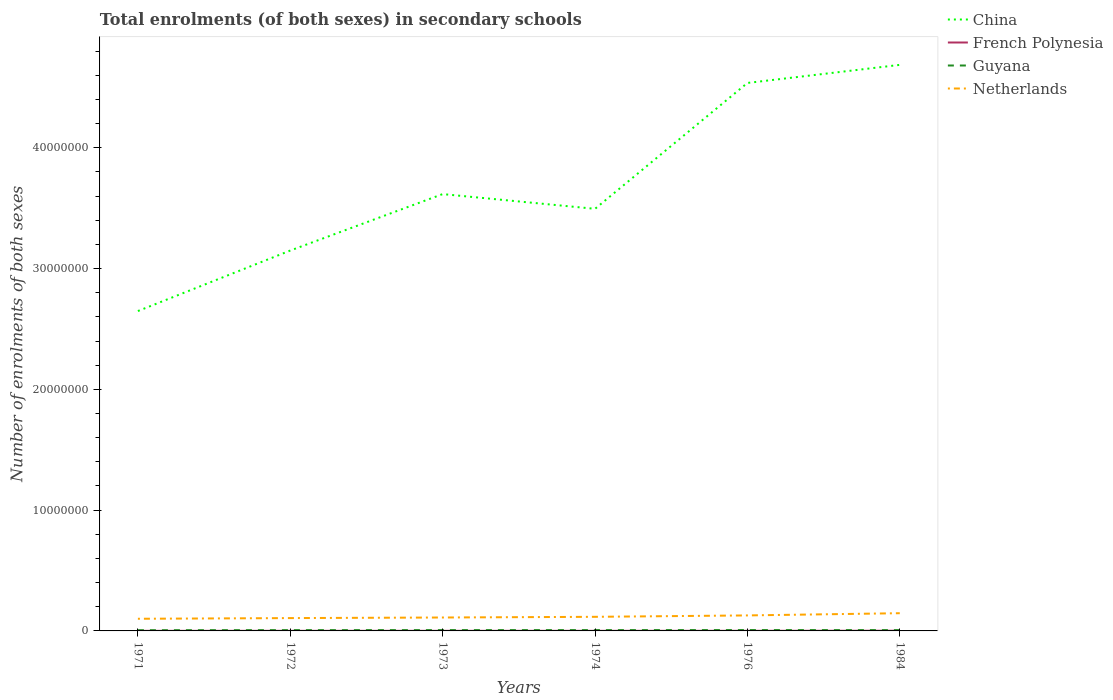Does the line corresponding to China intersect with the line corresponding to French Polynesia?
Offer a terse response. No. Is the number of lines equal to the number of legend labels?
Your response must be concise. Yes. Across all years, what is the maximum number of enrolments in secondary schools in Netherlands?
Offer a very short reply. 1.01e+06. In which year was the number of enrolments in secondary schools in Guyana maximum?
Give a very brief answer. 1971. What is the total number of enrolments in secondary schools in French Polynesia in the graph?
Provide a succinct answer. -1259. What is the difference between the highest and the second highest number of enrolments in secondary schools in Guyana?
Offer a very short reply. 1.09e+04. What is the difference between the highest and the lowest number of enrolments in secondary schools in Netherlands?
Ensure brevity in your answer.  2. How many lines are there?
Make the answer very short. 4. What is the difference between two consecutive major ticks on the Y-axis?
Your response must be concise. 1.00e+07. Are the values on the major ticks of Y-axis written in scientific E-notation?
Offer a terse response. No. Does the graph contain any zero values?
Your response must be concise. No. How are the legend labels stacked?
Make the answer very short. Vertical. What is the title of the graph?
Your answer should be compact. Total enrolments (of both sexes) in secondary schools. Does "Turks and Caicos Islands" appear as one of the legend labels in the graph?
Give a very brief answer. No. What is the label or title of the X-axis?
Your answer should be compact. Years. What is the label or title of the Y-axis?
Offer a very short reply. Number of enrolments of both sexes. What is the Number of enrolments of both sexes of China in 1971?
Your answer should be compact. 2.65e+07. What is the Number of enrolments of both sexes in French Polynesia in 1971?
Your answer should be compact. 6492. What is the Number of enrolments of both sexes of Guyana in 1971?
Keep it short and to the point. 6.04e+04. What is the Number of enrolments of both sexes in Netherlands in 1971?
Your answer should be compact. 1.01e+06. What is the Number of enrolments of both sexes of China in 1972?
Offer a very short reply. 3.15e+07. What is the Number of enrolments of both sexes of French Polynesia in 1972?
Offer a very short reply. 7542. What is the Number of enrolments of both sexes of Guyana in 1972?
Make the answer very short. 6.54e+04. What is the Number of enrolments of both sexes of Netherlands in 1972?
Offer a terse response. 1.06e+06. What is the Number of enrolments of both sexes in China in 1973?
Offer a very short reply. 3.62e+07. What is the Number of enrolments of both sexes in French Polynesia in 1973?
Provide a short and direct response. 7751. What is the Number of enrolments of both sexes in Guyana in 1973?
Give a very brief answer. 6.81e+04. What is the Number of enrolments of both sexes in Netherlands in 1973?
Offer a terse response. 1.11e+06. What is the Number of enrolments of both sexes of China in 1974?
Make the answer very short. 3.49e+07. What is the Number of enrolments of both sexes of French Polynesia in 1974?
Make the answer very short. 8126. What is the Number of enrolments of both sexes in Guyana in 1974?
Provide a short and direct response. 6.79e+04. What is the Number of enrolments of both sexes of Netherlands in 1974?
Your answer should be compact. 1.17e+06. What is the Number of enrolments of both sexes in China in 1976?
Ensure brevity in your answer.  4.54e+07. What is the Number of enrolments of both sexes of French Polynesia in 1976?
Offer a terse response. 9035. What is the Number of enrolments of both sexes in Guyana in 1976?
Keep it short and to the point. 7.13e+04. What is the Number of enrolments of both sexes in Netherlands in 1976?
Offer a very short reply. 1.28e+06. What is the Number of enrolments of both sexes of China in 1984?
Provide a succinct answer. 4.69e+07. What is the Number of enrolments of both sexes of French Polynesia in 1984?
Your response must be concise. 1.57e+04. What is the Number of enrolments of both sexes of Guyana in 1984?
Your response must be concise. 6.74e+04. What is the Number of enrolments of both sexes in Netherlands in 1984?
Offer a terse response. 1.47e+06. Across all years, what is the maximum Number of enrolments of both sexes in China?
Your response must be concise. 4.69e+07. Across all years, what is the maximum Number of enrolments of both sexes in French Polynesia?
Offer a terse response. 1.57e+04. Across all years, what is the maximum Number of enrolments of both sexes in Guyana?
Provide a short and direct response. 7.13e+04. Across all years, what is the maximum Number of enrolments of both sexes of Netherlands?
Ensure brevity in your answer.  1.47e+06. Across all years, what is the minimum Number of enrolments of both sexes in China?
Provide a short and direct response. 2.65e+07. Across all years, what is the minimum Number of enrolments of both sexes of French Polynesia?
Keep it short and to the point. 6492. Across all years, what is the minimum Number of enrolments of both sexes in Guyana?
Keep it short and to the point. 6.04e+04. Across all years, what is the minimum Number of enrolments of both sexes of Netherlands?
Provide a succinct answer. 1.01e+06. What is the total Number of enrolments of both sexes in China in the graph?
Your response must be concise. 2.21e+08. What is the total Number of enrolments of both sexes of French Polynesia in the graph?
Make the answer very short. 5.47e+04. What is the total Number of enrolments of both sexes of Guyana in the graph?
Make the answer very short. 4.00e+05. What is the total Number of enrolments of both sexes of Netherlands in the graph?
Ensure brevity in your answer.  7.10e+06. What is the difference between the Number of enrolments of both sexes in China in 1971 and that in 1972?
Give a very brief answer. -5.01e+06. What is the difference between the Number of enrolments of both sexes in French Polynesia in 1971 and that in 1972?
Your answer should be very brief. -1050. What is the difference between the Number of enrolments of both sexes of Guyana in 1971 and that in 1972?
Keep it short and to the point. -5000. What is the difference between the Number of enrolments of both sexes of Netherlands in 1971 and that in 1972?
Ensure brevity in your answer.  -5.63e+04. What is the difference between the Number of enrolments of both sexes in China in 1971 and that in 1973?
Offer a very short reply. -9.68e+06. What is the difference between the Number of enrolments of both sexes of French Polynesia in 1971 and that in 1973?
Your answer should be compact. -1259. What is the difference between the Number of enrolments of both sexes of Guyana in 1971 and that in 1973?
Ensure brevity in your answer.  -7680. What is the difference between the Number of enrolments of both sexes of Netherlands in 1971 and that in 1973?
Your answer should be compact. -1.05e+05. What is the difference between the Number of enrolments of both sexes of China in 1971 and that in 1974?
Your answer should be very brief. -8.46e+06. What is the difference between the Number of enrolments of both sexes in French Polynesia in 1971 and that in 1974?
Ensure brevity in your answer.  -1634. What is the difference between the Number of enrolments of both sexes of Guyana in 1971 and that in 1974?
Your answer should be very brief. -7441. What is the difference between the Number of enrolments of both sexes of Netherlands in 1971 and that in 1974?
Provide a succinct answer. -1.61e+05. What is the difference between the Number of enrolments of both sexes of China in 1971 and that in 1976?
Provide a short and direct response. -1.89e+07. What is the difference between the Number of enrolments of both sexes of French Polynesia in 1971 and that in 1976?
Keep it short and to the point. -2543. What is the difference between the Number of enrolments of both sexes in Guyana in 1971 and that in 1976?
Provide a succinct answer. -1.09e+04. What is the difference between the Number of enrolments of both sexes in Netherlands in 1971 and that in 1976?
Make the answer very short. -2.77e+05. What is the difference between the Number of enrolments of both sexes in China in 1971 and that in 1984?
Offer a very short reply. -2.04e+07. What is the difference between the Number of enrolments of both sexes of French Polynesia in 1971 and that in 1984?
Give a very brief answer. -9255. What is the difference between the Number of enrolments of both sexes of Guyana in 1971 and that in 1984?
Provide a succinct answer. -6950. What is the difference between the Number of enrolments of both sexes in Netherlands in 1971 and that in 1984?
Give a very brief answer. -4.61e+05. What is the difference between the Number of enrolments of both sexes in China in 1972 and that in 1973?
Your answer should be very brief. -4.67e+06. What is the difference between the Number of enrolments of both sexes of French Polynesia in 1972 and that in 1973?
Keep it short and to the point. -209. What is the difference between the Number of enrolments of both sexes in Guyana in 1972 and that in 1973?
Your answer should be very brief. -2680. What is the difference between the Number of enrolments of both sexes in Netherlands in 1972 and that in 1973?
Keep it short and to the point. -4.83e+04. What is the difference between the Number of enrolments of both sexes of China in 1972 and that in 1974?
Ensure brevity in your answer.  -3.45e+06. What is the difference between the Number of enrolments of both sexes in French Polynesia in 1972 and that in 1974?
Keep it short and to the point. -584. What is the difference between the Number of enrolments of both sexes of Guyana in 1972 and that in 1974?
Keep it short and to the point. -2441. What is the difference between the Number of enrolments of both sexes in Netherlands in 1972 and that in 1974?
Provide a succinct answer. -1.05e+05. What is the difference between the Number of enrolments of both sexes of China in 1972 and that in 1976?
Provide a short and direct response. -1.39e+07. What is the difference between the Number of enrolments of both sexes of French Polynesia in 1972 and that in 1976?
Your answer should be compact. -1493. What is the difference between the Number of enrolments of both sexes of Guyana in 1972 and that in 1976?
Make the answer very short. -5915. What is the difference between the Number of enrolments of both sexes in Netherlands in 1972 and that in 1976?
Provide a succinct answer. -2.21e+05. What is the difference between the Number of enrolments of both sexes of China in 1972 and that in 1984?
Your answer should be compact. -1.54e+07. What is the difference between the Number of enrolments of both sexes in French Polynesia in 1972 and that in 1984?
Provide a succinct answer. -8205. What is the difference between the Number of enrolments of both sexes of Guyana in 1972 and that in 1984?
Provide a short and direct response. -1950. What is the difference between the Number of enrolments of both sexes of Netherlands in 1972 and that in 1984?
Offer a very short reply. -4.04e+05. What is the difference between the Number of enrolments of both sexes of China in 1973 and that in 1974?
Give a very brief answer. 1.22e+06. What is the difference between the Number of enrolments of both sexes in French Polynesia in 1973 and that in 1974?
Make the answer very short. -375. What is the difference between the Number of enrolments of both sexes in Guyana in 1973 and that in 1974?
Provide a succinct answer. 239. What is the difference between the Number of enrolments of both sexes in Netherlands in 1973 and that in 1974?
Ensure brevity in your answer.  -5.65e+04. What is the difference between the Number of enrolments of both sexes in China in 1973 and that in 1976?
Give a very brief answer. -9.20e+06. What is the difference between the Number of enrolments of both sexes in French Polynesia in 1973 and that in 1976?
Your answer should be compact. -1284. What is the difference between the Number of enrolments of both sexes in Guyana in 1973 and that in 1976?
Make the answer very short. -3235. What is the difference between the Number of enrolments of both sexes of Netherlands in 1973 and that in 1976?
Your response must be concise. -1.73e+05. What is the difference between the Number of enrolments of both sexes in China in 1973 and that in 1984?
Offer a very short reply. -1.07e+07. What is the difference between the Number of enrolments of both sexes in French Polynesia in 1973 and that in 1984?
Provide a short and direct response. -7996. What is the difference between the Number of enrolments of both sexes of Guyana in 1973 and that in 1984?
Give a very brief answer. 730. What is the difference between the Number of enrolments of both sexes of Netherlands in 1973 and that in 1984?
Your answer should be very brief. -3.56e+05. What is the difference between the Number of enrolments of both sexes in China in 1974 and that in 1976?
Your answer should be compact. -1.04e+07. What is the difference between the Number of enrolments of both sexes in French Polynesia in 1974 and that in 1976?
Make the answer very short. -909. What is the difference between the Number of enrolments of both sexes of Guyana in 1974 and that in 1976?
Your answer should be very brief. -3474. What is the difference between the Number of enrolments of both sexes of Netherlands in 1974 and that in 1976?
Offer a terse response. -1.16e+05. What is the difference between the Number of enrolments of both sexes of China in 1974 and that in 1984?
Make the answer very short. -1.19e+07. What is the difference between the Number of enrolments of both sexes in French Polynesia in 1974 and that in 1984?
Offer a very short reply. -7621. What is the difference between the Number of enrolments of both sexes in Guyana in 1974 and that in 1984?
Ensure brevity in your answer.  491. What is the difference between the Number of enrolments of both sexes of Netherlands in 1974 and that in 1984?
Provide a succinct answer. -2.99e+05. What is the difference between the Number of enrolments of both sexes in China in 1976 and that in 1984?
Provide a short and direct response. -1.50e+06. What is the difference between the Number of enrolments of both sexes in French Polynesia in 1976 and that in 1984?
Offer a very short reply. -6712. What is the difference between the Number of enrolments of both sexes in Guyana in 1976 and that in 1984?
Make the answer very short. 3965. What is the difference between the Number of enrolments of both sexes of Netherlands in 1976 and that in 1984?
Your answer should be very brief. -1.83e+05. What is the difference between the Number of enrolments of both sexes in China in 1971 and the Number of enrolments of both sexes in French Polynesia in 1972?
Keep it short and to the point. 2.65e+07. What is the difference between the Number of enrolments of both sexes in China in 1971 and the Number of enrolments of both sexes in Guyana in 1972?
Your response must be concise. 2.64e+07. What is the difference between the Number of enrolments of both sexes of China in 1971 and the Number of enrolments of both sexes of Netherlands in 1972?
Your response must be concise. 2.54e+07. What is the difference between the Number of enrolments of both sexes in French Polynesia in 1971 and the Number of enrolments of both sexes in Guyana in 1972?
Your response must be concise. -5.89e+04. What is the difference between the Number of enrolments of both sexes in French Polynesia in 1971 and the Number of enrolments of both sexes in Netherlands in 1972?
Give a very brief answer. -1.06e+06. What is the difference between the Number of enrolments of both sexes in Guyana in 1971 and the Number of enrolments of both sexes in Netherlands in 1972?
Offer a very short reply. -1.00e+06. What is the difference between the Number of enrolments of both sexes of China in 1971 and the Number of enrolments of both sexes of French Polynesia in 1973?
Provide a succinct answer. 2.65e+07. What is the difference between the Number of enrolments of both sexes of China in 1971 and the Number of enrolments of both sexes of Guyana in 1973?
Offer a terse response. 2.64e+07. What is the difference between the Number of enrolments of both sexes in China in 1971 and the Number of enrolments of both sexes in Netherlands in 1973?
Your answer should be compact. 2.54e+07. What is the difference between the Number of enrolments of both sexes of French Polynesia in 1971 and the Number of enrolments of both sexes of Guyana in 1973?
Provide a succinct answer. -6.16e+04. What is the difference between the Number of enrolments of both sexes of French Polynesia in 1971 and the Number of enrolments of both sexes of Netherlands in 1973?
Your answer should be very brief. -1.10e+06. What is the difference between the Number of enrolments of both sexes of Guyana in 1971 and the Number of enrolments of both sexes of Netherlands in 1973?
Your answer should be compact. -1.05e+06. What is the difference between the Number of enrolments of both sexes of China in 1971 and the Number of enrolments of both sexes of French Polynesia in 1974?
Give a very brief answer. 2.65e+07. What is the difference between the Number of enrolments of both sexes of China in 1971 and the Number of enrolments of both sexes of Guyana in 1974?
Offer a very short reply. 2.64e+07. What is the difference between the Number of enrolments of both sexes of China in 1971 and the Number of enrolments of both sexes of Netherlands in 1974?
Offer a very short reply. 2.53e+07. What is the difference between the Number of enrolments of both sexes of French Polynesia in 1971 and the Number of enrolments of both sexes of Guyana in 1974?
Your answer should be very brief. -6.14e+04. What is the difference between the Number of enrolments of both sexes in French Polynesia in 1971 and the Number of enrolments of both sexes in Netherlands in 1974?
Make the answer very short. -1.16e+06. What is the difference between the Number of enrolments of both sexes in Guyana in 1971 and the Number of enrolments of both sexes in Netherlands in 1974?
Your answer should be compact. -1.11e+06. What is the difference between the Number of enrolments of both sexes of China in 1971 and the Number of enrolments of both sexes of French Polynesia in 1976?
Offer a terse response. 2.65e+07. What is the difference between the Number of enrolments of both sexes of China in 1971 and the Number of enrolments of both sexes of Guyana in 1976?
Your answer should be compact. 2.64e+07. What is the difference between the Number of enrolments of both sexes of China in 1971 and the Number of enrolments of both sexes of Netherlands in 1976?
Your answer should be compact. 2.52e+07. What is the difference between the Number of enrolments of both sexes in French Polynesia in 1971 and the Number of enrolments of both sexes in Guyana in 1976?
Provide a succinct answer. -6.48e+04. What is the difference between the Number of enrolments of both sexes in French Polynesia in 1971 and the Number of enrolments of both sexes in Netherlands in 1976?
Keep it short and to the point. -1.28e+06. What is the difference between the Number of enrolments of both sexes of Guyana in 1971 and the Number of enrolments of both sexes of Netherlands in 1976?
Give a very brief answer. -1.22e+06. What is the difference between the Number of enrolments of both sexes of China in 1971 and the Number of enrolments of both sexes of French Polynesia in 1984?
Offer a terse response. 2.65e+07. What is the difference between the Number of enrolments of both sexes in China in 1971 and the Number of enrolments of both sexes in Guyana in 1984?
Keep it short and to the point. 2.64e+07. What is the difference between the Number of enrolments of both sexes in China in 1971 and the Number of enrolments of both sexes in Netherlands in 1984?
Offer a very short reply. 2.50e+07. What is the difference between the Number of enrolments of both sexes in French Polynesia in 1971 and the Number of enrolments of both sexes in Guyana in 1984?
Give a very brief answer. -6.09e+04. What is the difference between the Number of enrolments of both sexes in French Polynesia in 1971 and the Number of enrolments of both sexes in Netherlands in 1984?
Offer a very short reply. -1.46e+06. What is the difference between the Number of enrolments of both sexes in Guyana in 1971 and the Number of enrolments of both sexes in Netherlands in 1984?
Your answer should be very brief. -1.41e+06. What is the difference between the Number of enrolments of both sexes in China in 1972 and the Number of enrolments of both sexes in French Polynesia in 1973?
Your answer should be compact. 3.15e+07. What is the difference between the Number of enrolments of both sexes of China in 1972 and the Number of enrolments of both sexes of Guyana in 1973?
Give a very brief answer. 3.14e+07. What is the difference between the Number of enrolments of both sexes in China in 1972 and the Number of enrolments of both sexes in Netherlands in 1973?
Offer a terse response. 3.04e+07. What is the difference between the Number of enrolments of both sexes of French Polynesia in 1972 and the Number of enrolments of both sexes of Guyana in 1973?
Give a very brief answer. -6.06e+04. What is the difference between the Number of enrolments of both sexes of French Polynesia in 1972 and the Number of enrolments of both sexes of Netherlands in 1973?
Provide a succinct answer. -1.10e+06. What is the difference between the Number of enrolments of both sexes of Guyana in 1972 and the Number of enrolments of both sexes of Netherlands in 1973?
Give a very brief answer. -1.05e+06. What is the difference between the Number of enrolments of both sexes of China in 1972 and the Number of enrolments of both sexes of French Polynesia in 1974?
Ensure brevity in your answer.  3.15e+07. What is the difference between the Number of enrolments of both sexes of China in 1972 and the Number of enrolments of both sexes of Guyana in 1974?
Offer a terse response. 3.14e+07. What is the difference between the Number of enrolments of both sexes of China in 1972 and the Number of enrolments of both sexes of Netherlands in 1974?
Provide a short and direct response. 3.03e+07. What is the difference between the Number of enrolments of both sexes of French Polynesia in 1972 and the Number of enrolments of both sexes of Guyana in 1974?
Offer a very short reply. -6.03e+04. What is the difference between the Number of enrolments of both sexes of French Polynesia in 1972 and the Number of enrolments of both sexes of Netherlands in 1974?
Your answer should be compact. -1.16e+06. What is the difference between the Number of enrolments of both sexes in Guyana in 1972 and the Number of enrolments of both sexes in Netherlands in 1974?
Provide a succinct answer. -1.10e+06. What is the difference between the Number of enrolments of both sexes of China in 1972 and the Number of enrolments of both sexes of French Polynesia in 1976?
Offer a terse response. 3.15e+07. What is the difference between the Number of enrolments of both sexes in China in 1972 and the Number of enrolments of both sexes in Guyana in 1976?
Your answer should be compact. 3.14e+07. What is the difference between the Number of enrolments of both sexes of China in 1972 and the Number of enrolments of both sexes of Netherlands in 1976?
Ensure brevity in your answer.  3.02e+07. What is the difference between the Number of enrolments of both sexes of French Polynesia in 1972 and the Number of enrolments of both sexes of Guyana in 1976?
Your response must be concise. -6.38e+04. What is the difference between the Number of enrolments of both sexes in French Polynesia in 1972 and the Number of enrolments of both sexes in Netherlands in 1976?
Your answer should be very brief. -1.28e+06. What is the difference between the Number of enrolments of both sexes of Guyana in 1972 and the Number of enrolments of both sexes of Netherlands in 1976?
Your answer should be compact. -1.22e+06. What is the difference between the Number of enrolments of both sexes in China in 1972 and the Number of enrolments of both sexes in French Polynesia in 1984?
Offer a terse response. 3.15e+07. What is the difference between the Number of enrolments of both sexes of China in 1972 and the Number of enrolments of both sexes of Guyana in 1984?
Offer a terse response. 3.14e+07. What is the difference between the Number of enrolments of both sexes in China in 1972 and the Number of enrolments of both sexes in Netherlands in 1984?
Keep it short and to the point. 3.00e+07. What is the difference between the Number of enrolments of both sexes of French Polynesia in 1972 and the Number of enrolments of both sexes of Guyana in 1984?
Your response must be concise. -5.98e+04. What is the difference between the Number of enrolments of both sexes in French Polynesia in 1972 and the Number of enrolments of both sexes in Netherlands in 1984?
Keep it short and to the point. -1.46e+06. What is the difference between the Number of enrolments of both sexes in Guyana in 1972 and the Number of enrolments of both sexes in Netherlands in 1984?
Make the answer very short. -1.40e+06. What is the difference between the Number of enrolments of both sexes in China in 1973 and the Number of enrolments of both sexes in French Polynesia in 1974?
Give a very brief answer. 3.62e+07. What is the difference between the Number of enrolments of both sexes of China in 1973 and the Number of enrolments of both sexes of Guyana in 1974?
Keep it short and to the point. 3.61e+07. What is the difference between the Number of enrolments of both sexes in China in 1973 and the Number of enrolments of both sexes in Netherlands in 1974?
Your response must be concise. 3.50e+07. What is the difference between the Number of enrolments of both sexes in French Polynesia in 1973 and the Number of enrolments of both sexes in Guyana in 1974?
Your answer should be very brief. -6.01e+04. What is the difference between the Number of enrolments of both sexes of French Polynesia in 1973 and the Number of enrolments of both sexes of Netherlands in 1974?
Your answer should be very brief. -1.16e+06. What is the difference between the Number of enrolments of both sexes in Guyana in 1973 and the Number of enrolments of both sexes in Netherlands in 1974?
Provide a succinct answer. -1.10e+06. What is the difference between the Number of enrolments of both sexes in China in 1973 and the Number of enrolments of both sexes in French Polynesia in 1976?
Ensure brevity in your answer.  3.62e+07. What is the difference between the Number of enrolments of both sexes of China in 1973 and the Number of enrolments of both sexes of Guyana in 1976?
Offer a very short reply. 3.61e+07. What is the difference between the Number of enrolments of both sexes of China in 1973 and the Number of enrolments of both sexes of Netherlands in 1976?
Your answer should be compact. 3.49e+07. What is the difference between the Number of enrolments of both sexes of French Polynesia in 1973 and the Number of enrolments of both sexes of Guyana in 1976?
Offer a very short reply. -6.36e+04. What is the difference between the Number of enrolments of both sexes in French Polynesia in 1973 and the Number of enrolments of both sexes in Netherlands in 1976?
Ensure brevity in your answer.  -1.28e+06. What is the difference between the Number of enrolments of both sexes in Guyana in 1973 and the Number of enrolments of both sexes in Netherlands in 1976?
Ensure brevity in your answer.  -1.22e+06. What is the difference between the Number of enrolments of both sexes of China in 1973 and the Number of enrolments of both sexes of French Polynesia in 1984?
Your answer should be very brief. 3.62e+07. What is the difference between the Number of enrolments of both sexes in China in 1973 and the Number of enrolments of both sexes in Guyana in 1984?
Give a very brief answer. 3.61e+07. What is the difference between the Number of enrolments of both sexes in China in 1973 and the Number of enrolments of both sexes in Netherlands in 1984?
Give a very brief answer. 3.47e+07. What is the difference between the Number of enrolments of both sexes in French Polynesia in 1973 and the Number of enrolments of both sexes in Guyana in 1984?
Provide a succinct answer. -5.96e+04. What is the difference between the Number of enrolments of both sexes of French Polynesia in 1973 and the Number of enrolments of both sexes of Netherlands in 1984?
Make the answer very short. -1.46e+06. What is the difference between the Number of enrolments of both sexes in Guyana in 1973 and the Number of enrolments of both sexes in Netherlands in 1984?
Your answer should be very brief. -1.40e+06. What is the difference between the Number of enrolments of both sexes of China in 1974 and the Number of enrolments of both sexes of French Polynesia in 1976?
Offer a very short reply. 3.49e+07. What is the difference between the Number of enrolments of both sexes of China in 1974 and the Number of enrolments of both sexes of Guyana in 1976?
Keep it short and to the point. 3.49e+07. What is the difference between the Number of enrolments of both sexes in China in 1974 and the Number of enrolments of both sexes in Netherlands in 1976?
Provide a short and direct response. 3.37e+07. What is the difference between the Number of enrolments of both sexes in French Polynesia in 1974 and the Number of enrolments of both sexes in Guyana in 1976?
Provide a succinct answer. -6.32e+04. What is the difference between the Number of enrolments of both sexes of French Polynesia in 1974 and the Number of enrolments of both sexes of Netherlands in 1976?
Your answer should be very brief. -1.28e+06. What is the difference between the Number of enrolments of both sexes in Guyana in 1974 and the Number of enrolments of both sexes in Netherlands in 1976?
Ensure brevity in your answer.  -1.22e+06. What is the difference between the Number of enrolments of both sexes in China in 1974 and the Number of enrolments of both sexes in French Polynesia in 1984?
Make the answer very short. 3.49e+07. What is the difference between the Number of enrolments of both sexes in China in 1974 and the Number of enrolments of both sexes in Guyana in 1984?
Provide a short and direct response. 3.49e+07. What is the difference between the Number of enrolments of both sexes in China in 1974 and the Number of enrolments of both sexes in Netherlands in 1984?
Keep it short and to the point. 3.35e+07. What is the difference between the Number of enrolments of both sexes in French Polynesia in 1974 and the Number of enrolments of both sexes in Guyana in 1984?
Give a very brief answer. -5.92e+04. What is the difference between the Number of enrolments of both sexes of French Polynesia in 1974 and the Number of enrolments of both sexes of Netherlands in 1984?
Keep it short and to the point. -1.46e+06. What is the difference between the Number of enrolments of both sexes of Guyana in 1974 and the Number of enrolments of both sexes of Netherlands in 1984?
Offer a terse response. -1.40e+06. What is the difference between the Number of enrolments of both sexes of China in 1976 and the Number of enrolments of both sexes of French Polynesia in 1984?
Ensure brevity in your answer.  4.54e+07. What is the difference between the Number of enrolments of both sexes in China in 1976 and the Number of enrolments of both sexes in Guyana in 1984?
Your answer should be very brief. 4.53e+07. What is the difference between the Number of enrolments of both sexes of China in 1976 and the Number of enrolments of both sexes of Netherlands in 1984?
Your answer should be compact. 4.39e+07. What is the difference between the Number of enrolments of both sexes in French Polynesia in 1976 and the Number of enrolments of both sexes in Guyana in 1984?
Offer a terse response. -5.83e+04. What is the difference between the Number of enrolments of both sexes in French Polynesia in 1976 and the Number of enrolments of both sexes in Netherlands in 1984?
Your response must be concise. -1.46e+06. What is the difference between the Number of enrolments of both sexes of Guyana in 1976 and the Number of enrolments of both sexes of Netherlands in 1984?
Your answer should be very brief. -1.40e+06. What is the average Number of enrolments of both sexes in China per year?
Your response must be concise. 3.69e+07. What is the average Number of enrolments of both sexes in French Polynesia per year?
Give a very brief answer. 9115.5. What is the average Number of enrolments of both sexes of Guyana per year?
Offer a very short reply. 6.67e+04. What is the average Number of enrolments of both sexes of Netherlands per year?
Offer a terse response. 1.18e+06. In the year 1971, what is the difference between the Number of enrolments of both sexes in China and Number of enrolments of both sexes in French Polynesia?
Offer a very short reply. 2.65e+07. In the year 1971, what is the difference between the Number of enrolments of both sexes of China and Number of enrolments of both sexes of Guyana?
Provide a succinct answer. 2.64e+07. In the year 1971, what is the difference between the Number of enrolments of both sexes of China and Number of enrolments of both sexes of Netherlands?
Your response must be concise. 2.55e+07. In the year 1971, what is the difference between the Number of enrolments of both sexes of French Polynesia and Number of enrolments of both sexes of Guyana?
Make the answer very short. -5.39e+04. In the year 1971, what is the difference between the Number of enrolments of both sexes of French Polynesia and Number of enrolments of both sexes of Netherlands?
Give a very brief answer. -1.00e+06. In the year 1971, what is the difference between the Number of enrolments of both sexes in Guyana and Number of enrolments of both sexes in Netherlands?
Offer a very short reply. -9.46e+05. In the year 1972, what is the difference between the Number of enrolments of both sexes of China and Number of enrolments of both sexes of French Polynesia?
Offer a terse response. 3.15e+07. In the year 1972, what is the difference between the Number of enrolments of both sexes of China and Number of enrolments of both sexes of Guyana?
Ensure brevity in your answer.  3.14e+07. In the year 1972, what is the difference between the Number of enrolments of both sexes in China and Number of enrolments of both sexes in Netherlands?
Your answer should be very brief. 3.04e+07. In the year 1972, what is the difference between the Number of enrolments of both sexes in French Polynesia and Number of enrolments of both sexes in Guyana?
Offer a very short reply. -5.79e+04. In the year 1972, what is the difference between the Number of enrolments of both sexes in French Polynesia and Number of enrolments of both sexes in Netherlands?
Provide a succinct answer. -1.06e+06. In the year 1972, what is the difference between the Number of enrolments of both sexes of Guyana and Number of enrolments of both sexes of Netherlands?
Offer a terse response. -9.97e+05. In the year 1973, what is the difference between the Number of enrolments of both sexes of China and Number of enrolments of both sexes of French Polynesia?
Offer a very short reply. 3.62e+07. In the year 1973, what is the difference between the Number of enrolments of both sexes of China and Number of enrolments of both sexes of Guyana?
Provide a short and direct response. 3.61e+07. In the year 1973, what is the difference between the Number of enrolments of both sexes of China and Number of enrolments of both sexes of Netherlands?
Offer a very short reply. 3.51e+07. In the year 1973, what is the difference between the Number of enrolments of both sexes of French Polynesia and Number of enrolments of both sexes of Guyana?
Keep it short and to the point. -6.03e+04. In the year 1973, what is the difference between the Number of enrolments of both sexes in French Polynesia and Number of enrolments of both sexes in Netherlands?
Your answer should be very brief. -1.10e+06. In the year 1973, what is the difference between the Number of enrolments of both sexes of Guyana and Number of enrolments of both sexes of Netherlands?
Offer a very short reply. -1.04e+06. In the year 1974, what is the difference between the Number of enrolments of both sexes of China and Number of enrolments of both sexes of French Polynesia?
Ensure brevity in your answer.  3.49e+07. In the year 1974, what is the difference between the Number of enrolments of both sexes of China and Number of enrolments of both sexes of Guyana?
Your response must be concise. 3.49e+07. In the year 1974, what is the difference between the Number of enrolments of both sexes in China and Number of enrolments of both sexes in Netherlands?
Provide a short and direct response. 3.38e+07. In the year 1974, what is the difference between the Number of enrolments of both sexes in French Polynesia and Number of enrolments of both sexes in Guyana?
Offer a terse response. -5.97e+04. In the year 1974, what is the difference between the Number of enrolments of both sexes of French Polynesia and Number of enrolments of both sexes of Netherlands?
Give a very brief answer. -1.16e+06. In the year 1974, what is the difference between the Number of enrolments of both sexes in Guyana and Number of enrolments of both sexes in Netherlands?
Provide a short and direct response. -1.10e+06. In the year 1976, what is the difference between the Number of enrolments of both sexes in China and Number of enrolments of both sexes in French Polynesia?
Ensure brevity in your answer.  4.54e+07. In the year 1976, what is the difference between the Number of enrolments of both sexes of China and Number of enrolments of both sexes of Guyana?
Your response must be concise. 4.53e+07. In the year 1976, what is the difference between the Number of enrolments of both sexes of China and Number of enrolments of both sexes of Netherlands?
Offer a very short reply. 4.41e+07. In the year 1976, what is the difference between the Number of enrolments of both sexes of French Polynesia and Number of enrolments of both sexes of Guyana?
Offer a terse response. -6.23e+04. In the year 1976, what is the difference between the Number of enrolments of both sexes in French Polynesia and Number of enrolments of both sexes in Netherlands?
Keep it short and to the point. -1.27e+06. In the year 1976, what is the difference between the Number of enrolments of both sexes in Guyana and Number of enrolments of both sexes in Netherlands?
Provide a succinct answer. -1.21e+06. In the year 1984, what is the difference between the Number of enrolments of both sexes in China and Number of enrolments of both sexes in French Polynesia?
Your answer should be compact. 4.68e+07. In the year 1984, what is the difference between the Number of enrolments of both sexes of China and Number of enrolments of both sexes of Guyana?
Offer a terse response. 4.68e+07. In the year 1984, what is the difference between the Number of enrolments of both sexes in China and Number of enrolments of both sexes in Netherlands?
Provide a short and direct response. 4.54e+07. In the year 1984, what is the difference between the Number of enrolments of both sexes of French Polynesia and Number of enrolments of both sexes of Guyana?
Your response must be concise. -5.16e+04. In the year 1984, what is the difference between the Number of enrolments of both sexes in French Polynesia and Number of enrolments of both sexes in Netherlands?
Keep it short and to the point. -1.45e+06. In the year 1984, what is the difference between the Number of enrolments of both sexes of Guyana and Number of enrolments of both sexes of Netherlands?
Provide a succinct answer. -1.40e+06. What is the ratio of the Number of enrolments of both sexes of China in 1971 to that in 1972?
Give a very brief answer. 0.84. What is the ratio of the Number of enrolments of both sexes in French Polynesia in 1971 to that in 1972?
Give a very brief answer. 0.86. What is the ratio of the Number of enrolments of both sexes of Guyana in 1971 to that in 1972?
Offer a terse response. 0.92. What is the ratio of the Number of enrolments of both sexes of Netherlands in 1971 to that in 1972?
Offer a terse response. 0.95. What is the ratio of the Number of enrolments of both sexes in China in 1971 to that in 1973?
Give a very brief answer. 0.73. What is the ratio of the Number of enrolments of both sexes of French Polynesia in 1971 to that in 1973?
Ensure brevity in your answer.  0.84. What is the ratio of the Number of enrolments of both sexes in Guyana in 1971 to that in 1973?
Ensure brevity in your answer.  0.89. What is the ratio of the Number of enrolments of both sexes of Netherlands in 1971 to that in 1973?
Provide a succinct answer. 0.91. What is the ratio of the Number of enrolments of both sexes in China in 1971 to that in 1974?
Your response must be concise. 0.76. What is the ratio of the Number of enrolments of both sexes of French Polynesia in 1971 to that in 1974?
Keep it short and to the point. 0.8. What is the ratio of the Number of enrolments of both sexes of Guyana in 1971 to that in 1974?
Offer a very short reply. 0.89. What is the ratio of the Number of enrolments of both sexes of Netherlands in 1971 to that in 1974?
Your answer should be very brief. 0.86. What is the ratio of the Number of enrolments of both sexes in China in 1971 to that in 1976?
Provide a short and direct response. 0.58. What is the ratio of the Number of enrolments of both sexes in French Polynesia in 1971 to that in 1976?
Offer a very short reply. 0.72. What is the ratio of the Number of enrolments of both sexes in Guyana in 1971 to that in 1976?
Offer a very short reply. 0.85. What is the ratio of the Number of enrolments of both sexes in Netherlands in 1971 to that in 1976?
Make the answer very short. 0.78. What is the ratio of the Number of enrolments of both sexes of China in 1971 to that in 1984?
Offer a terse response. 0.57. What is the ratio of the Number of enrolments of both sexes in French Polynesia in 1971 to that in 1984?
Give a very brief answer. 0.41. What is the ratio of the Number of enrolments of both sexes of Guyana in 1971 to that in 1984?
Provide a short and direct response. 0.9. What is the ratio of the Number of enrolments of both sexes in Netherlands in 1971 to that in 1984?
Your answer should be very brief. 0.69. What is the ratio of the Number of enrolments of both sexes of China in 1972 to that in 1973?
Keep it short and to the point. 0.87. What is the ratio of the Number of enrolments of both sexes in French Polynesia in 1972 to that in 1973?
Your response must be concise. 0.97. What is the ratio of the Number of enrolments of both sexes in Guyana in 1972 to that in 1973?
Offer a very short reply. 0.96. What is the ratio of the Number of enrolments of both sexes in Netherlands in 1972 to that in 1973?
Keep it short and to the point. 0.96. What is the ratio of the Number of enrolments of both sexes of China in 1972 to that in 1974?
Offer a terse response. 0.9. What is the ratio of the Number of enrolments of both sexes in French Polynesia in 1972 to that in 1974?
Make the answer very short. 0.93. What is the ratio of the Number of enrolments of both sexes in Guyana in 1972 to that in 1974?
Ensure brevity in your answer.  0.96. What is the ratio of the Number of enrolments of both sexes in Netherlands in 1972 to that in 1974?
Give a very brief answer. 0.91. What is the ratio of the Number of enrolments of both sexes of China in 1972 to that in 1976?
Your response must be concise. 0.69. What is the ratio of the Number of enrolments of both sexes of French Polynesia in 1972 to that in 1976?
Keep it short and to the point. 0.83. What is the ratio of the Number of enrolments of both sexes in Guyana in 1972 to that in 1976?
Your answer should be compact. 0.92. What is the ratio of the Number of enrolments of both sexes in Netherlands in 1972 to that in 1976?
Your answer should be very brief. 0.83. What is the ratio of the Number of enrolments of both sexes of China in 1972 to that in 1984?
Give a very brief answer. 0.67. What is the ratio of the Number of enrolments of both sexes of French Polynesia in 1972 to that in 1984?
Provide a short and direct response. 0.48. What is the ratio of the Number of enrolments of both sexes in Guyana in 1972 to that in 1984?
Your response must be concise. 0.97. What is the ratio of the Number of enrolments of both sexes in Netherlands in 1972 to that in 1984?
Your answer should be very brief. 0.72. What is the ratio of the Number of enrolments of both sexes of China in 1973 to that in 1974?
Your answer should be very brief. 1.03. What is the ratio of the Number of enrolments of both sexes in French Polynesia in 1973 to that in 1974?
Make the answer very short. 0.95. What is the ratio of the Number of enrolments of both sexes in Netherlands in 1973 to that in 1974?
Your answer should be compact. 0.95. What is the ratio of the Number of enrolments of both sexes of China in 1973 to that in 1976?
Keep it short and to the point. 0.8. What is the ratio of the Number of enrolments of both sexes of French Polynesia in 1973 to that in 1976?
Provide a succinct answer. 0.86. What is the ratio of the Number of enrolments of both sexes of Guyana in 1973 to that in 1976?
Your answer should be very brief. 0.95. What is the ratio of the Number of enrolments of both sexes of Netherlands in 1973 to that in 1976?
Provide a short and direct response. 0.87. What is the ratio of the Number of enrolments of both sexes of China in 1973 to that in 1984?
Offer a very short reply. 0.77. What is the ratio of the Number of enrolments of both sexes in French Polynesia in 1973 to that in 1984?
Offer a terse response. 0.49. What is the ratio of the Number of enrolments of both sexes in Guyana in 1973 to that in 1984?
Give a very brief answer. 1.01. What is the ratio of the Number of enrolments of both sexes of Netherlands in 1973 to that in 1984?
Offer a very short reply. 0.76. What is the ratio of the Number of enrolments of both sexes in China in 1974 to that in 1976?
Your response must be concise. 0.77. What is the ratio of the Number of enrolments of both sexes of French Polynesia in 1974 to that in 1976?
Give a very brief answer. 0.9. What is the ratio of the Number of enrolments of both sexes in Guyana in 1974 to that in 1976?
Give a very brief answer. 0.95. What is the ratio of the Number of enrolments of both sexes in Netherlands in 1974 to that in 1976?
Your answer should be compact. 0.91. What is the ratio of the Number of enrolments of both sexes of China in 1974 to that in 1984?
Offer a terse response. 0.75. What is the ratio of the Number of enrolments of both sexes of French Polynesia in 1974 to that in 1984?
Give a very brief answer. 0.52. What is the ratio of the Number of enrolments of both sexes in Guyana in 1974 to that in 1984?
Your response must be concise. 1.01. What is the ratio of the Number of enrolments of both sexes of Netherlands in 1974 to that in 1984?
Your response must be concise. 0.8. What is the ratio of the Number of enrolments of both sexes in China in 1976 to that in 1984?
Your answer should be very brief. 0.97. What is the ratio of the Number of enrolments of both sexes of French Polynesia in 1976 to that in 1984?
Offer a very short reply. 0.57. What is the ratio of the Number of enrolments of both sexes in Guyana in 1976 to that in 1984?
Your answer should be very brief. 1.06. What is the ratio of the Number of enrolments of both sexes in Netherlands in 1976 to that in 1984?
Your answer should be very brief. 0.88. What is the difference between the highest and the second highest Number of enrolments of both sexes in China?
Your answer should be very brief. 1.50e+06. What is the difference between the highest and the second highest Number of enrolments of both sexes of French Polynesia?
Provide a succinct answer. 6712. What is the difference between the highest and the second highest Number of enrolments of both sexes of Guyana?
Keep it short and to the point. 3235. What is the difference between the highest and the second highest Number of enrolments of both sexes in Netherlands?
Your response must be concise. 1.83e+05. What is the difference between the highest and the lowest Number of enrolments of both sexes of China?
Make the answer very short. 2.04e+07. What is the difference between the highest and the lowest Number of enrolments of both sexes of French Polynesia?
Offer a terse response. 9255. What is the difference between the highest and the lowest Number of enrolments of both sexes in Guyana?
Your answer should be compact. 1.09e+04. What is the difference between the highest and the lowest Number of enrolments of both sexes of Netherlands?
Provide a short and direct response. 4.61e+05. 